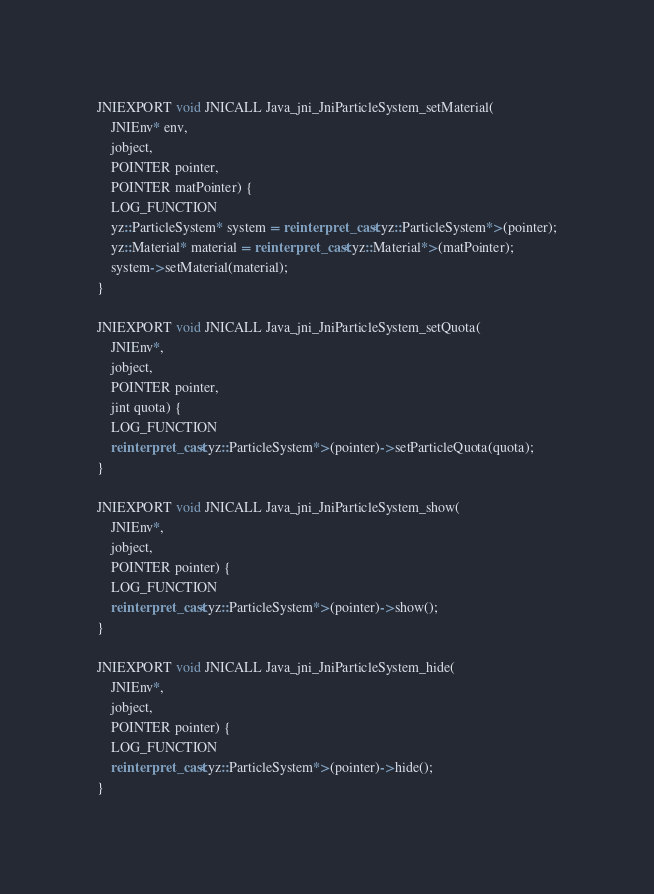<code> <loc_0><loc_0><loc_500><loc_500><_C++_>JNIEXPORT void JNICALL Java_jni_JniParticleSystem_setMaterial(
    JNIEnv* env,
    jobject,
    POINTER pointer,
    POINTER matPointer) {
    LOG_FUNCTION
    yz::ParticleSystem* system = reinterpret_cast<yz::ParticleSystem*>(pointer);
    yz::Material* material = reinterpret_cast<yz::Material*>(matPointer);
    system->setMaterial(material);
}

JNIEXPORT void JNICALL Java_jni_JniParticleSystem_setQuota(
    JNIEnv*,
    jobject,
    POINTER pointer,
    jint quota) {
    LOG_FUNCTION
    reinterpret_cast<yz::ParticleSystem*>(pointer)->setParticleQuota(quota);
}

JNIEXPORT void JNICALL Java_jni_JniParticleSystem_show(
    JNIEnv*,
    jobject,
    POINTER pointer) {
    LOG_FUNCTION
    reinterpret_cast<yz::ParticleSystem*>(pointer)->show();
}

JNIEXPORT void JNICALL Java_jni_JniParticleSystem_hide(
    JNIEnv*,
    jobject,
    POINTER pointer) {
    LOG_FUNCTION
    reinterpret_cast<yz::ParticleSystem*>(pointer)->hide();
}
</code> 